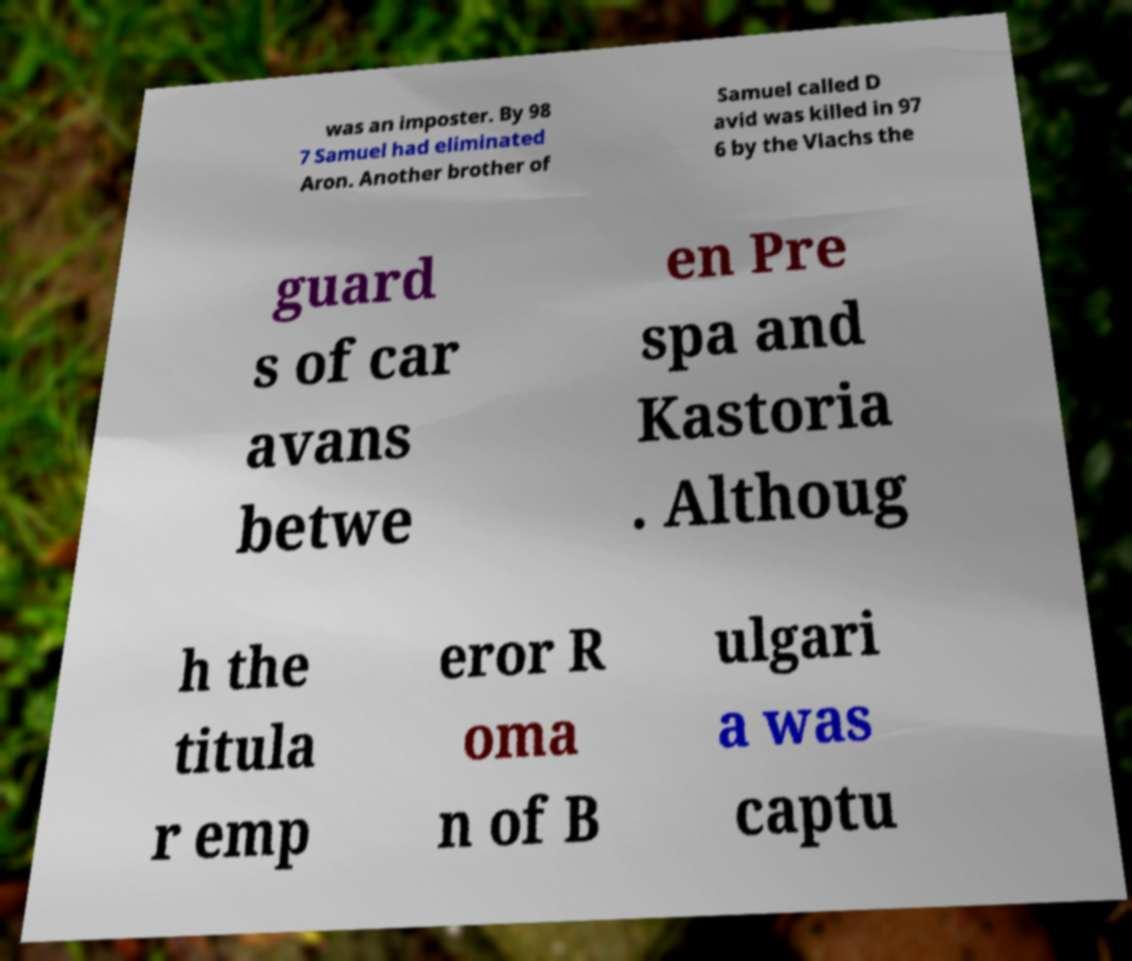I need the written content from this picture converted into text. Can you do that? was an imposter. By 98 7 Samuel had eliminated Aron. Another brother of Samuel called D avid was killed in 97 6 by the Vlachs the guard s of car avans betwe en Pre spa and Kastoria . Althoug h the titula r emp eror R oma n of B ulgari a was captu 